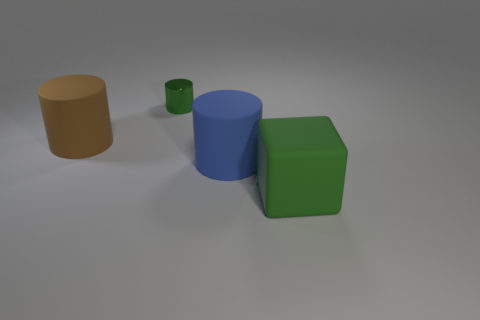Subtract all green cylinders. How many cylinders are left? 2 Add 3 green balls. How many objects exist? 7 Subtract all cylinders. How many objects are left? 1 Subtract all purple cylinders. Subtract all blue blocks. How many cylinders are left? 3 Subtract all small blue rubber spheres. Subtract all green cubes. How many objects are left? 3 Add 2 big green rubber blocks. How many big green rubber blocks are left? 3 Add 1 large gray matte spheres. How many large gray matte spheres exist? 1 Subtract 0 red cylinders. How many objects are left? 4 